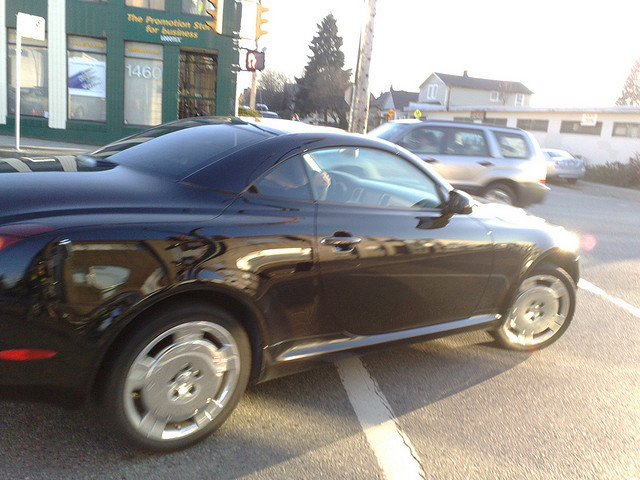Please extract the text content from this image. 1460 